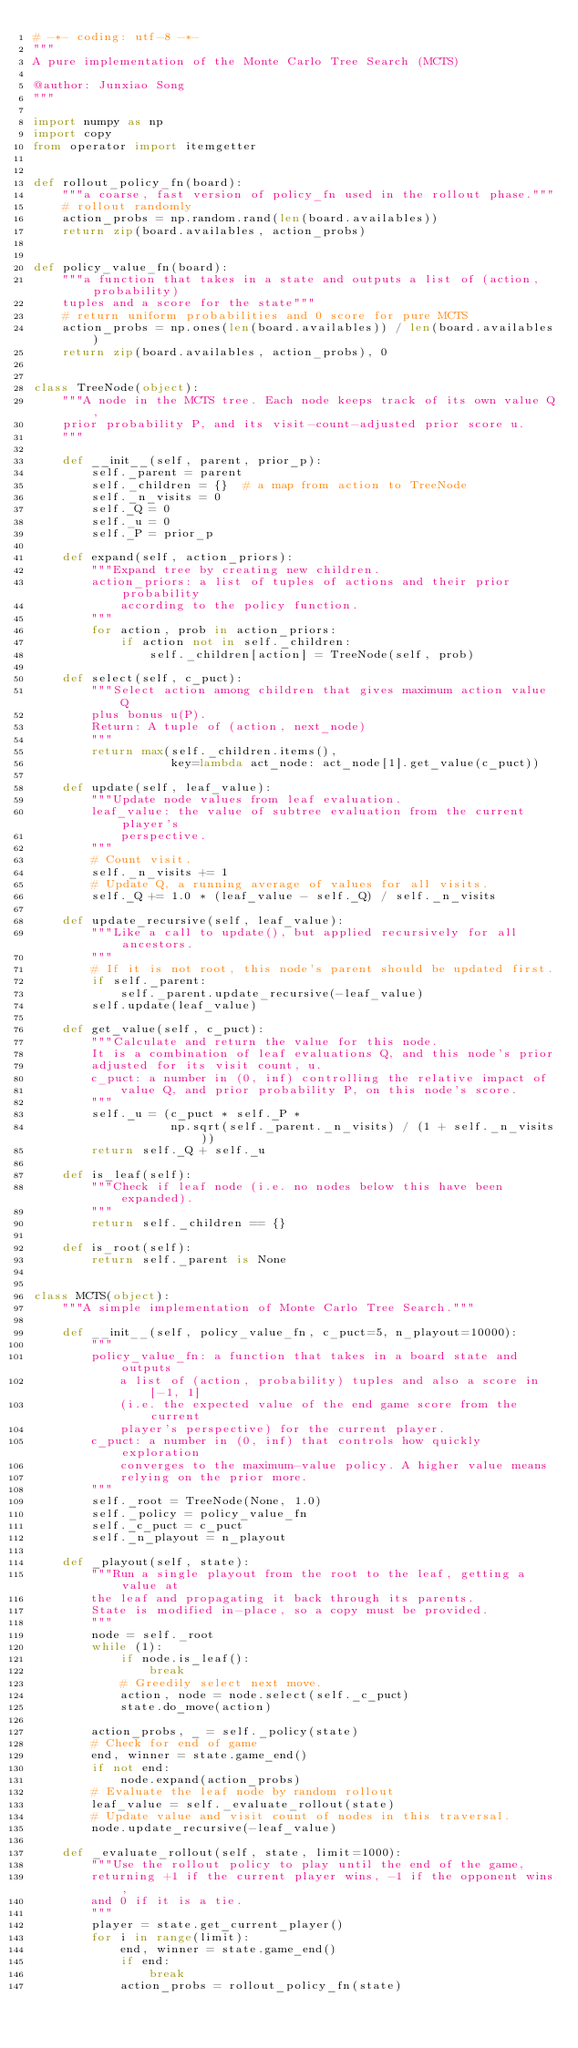Convert code to text. <code><loc_0><loc_0><loc_500><loc_500><_Python_># -*- coding: utf-8 -*-
"""
A pure implementation of the Monte Carlo Tree Search (MCTS)

@author: Junxiao Song
"""

import numpy as np
import copy
from operator import itemgetter


def rollout_policy_fn(board):
    """a coarse, fast version of policy_fn used in the rollout phase."""
    # rollout randomly
    action_probs = np.random.rand(len(board.availables))
    return zip(board.availables, action_probs)


def policy_value_fn(board):
    """a function that takes in a state and outputs a list of (action, probability)
    tuples and a score for the state"""
    # return uniform probabilities and 0 score for pure MCTS
    action_probs = np.ones(len(board.availables)) / len(board.availables)
    return zip(board.availables, action_probs), 0


class TreeNode(object):
    """A node in the MCTS tree. Each node keeps track of its own value Q,
    prior probability P, and its visit-count-adjusted prior score u.
    """

    def __init__(self, parent, prior_p):
        self._parent = parent
        self._children = {}  # a map from action to TreeNode
        self._n_visits = 0
        self._Q = 0
        self._u = 0
        self._P = prior_p

    def expand(self, action_priors):
        """Expand tree by creating new children.
        action_priors: a list of tuples of actions and their prior probability
            according to the policy function.
        """
        for action, prob in action_priors:
            if action not in self._children:
                self._children[action] = TreeNode(self, prob)

    def select(self, c_puct):
        """Select action among children that gives maximum action value Q
        plus bonus u(P).
        Return: A tuple of (action, next_node)
        """
        return max(self._children.items(),
                   key=lambda act_node: act_node[1].get_value(c_puct))

    def update(self, leaf_value):
        """Update node values from leaf evaluation.
        leaf_value: the value of subtree evaluation from the current player's
            perspective.
        """
        # Count visit.
        self._n_visits += 1
        # Update Q, a running average of values for all visits.
        self._Q += 1.0 * (leaf_value - self._Q) / self._n_visits

    def update_recursive(self, leaf_value):
        """Like a call to update(), but applied recursively for all ancestors.
        """
        # If it is not root, this node's parent should be updated first.
        if self._parent:
            self._parent.update_recursive(-leaf_value)
        self.update(leaf_value)

    def get_value(self, c_puct):
        """Calculate and return the value for this node.
        It is a combination of leaf evaluations Q, and this node's prior
        adjusted for its visit count, u.
        c_puct: a number in (0, inf) controlling the relative impact of
            value Q, and prior probability P, on this node's score.
        """
        self._u = (c_puct * self._P *
                   np.sqrt(self._parent._n_visits) / (1 + self._n_visits))
        return self._Q + self._u

    def is_leaf(self):
        """Check if leaf node (i.e. no nodes below this have been expanded).
        """
        return self._children == {}

    def is_root(self):
        return self._parent is None


class MCTS(object):
    """A simple implementation of Monte Carlo Tree Search."""

    def __init__(self, policy_value_fn, c_puct=5, n_playout=10000):
        """
        policy_value_fn: a function that takes in a board state and outputs
            a list of (action, probability) tuples and also a score in [-1, 1]
            (i.e. the expected value of the end game score from the current
            player's perspective) for the current player.
        c_puct: a number in (0, inf) that controls how quickly exploration
            converges to the maximum-value policy. A higher value means
            relying on the prior more.
        """
        self._root = TreeNode(None, 1.0)
        self._policy = policy_value_fn
        self._c_puct = c_puct
        self._n_playout = n_playout

    def _playout(self, state):
        """Run a single playout from the root to the leaf, getting a value at
        the leaf and propagating it back through its parents.
        State is modified in-place, so a copy must be provided.
        """
        node = self._root
        while (1):
            if node.is_leaf():
                break
            # Greedily select next move.
            action, node = node.select(self._c_puct)
            state.do_move(action)

        action_probs, _ = self._policy(state)
        # Check for end of game
        end, winner = state.game_end()
        if not end:
            node.expand(action_probs)
        # Evaluate the leaf node by random rollout
        leaf_value = self._evaluate_rollout(state)
        # Update value and visit count of nodes in this traversal.
        node.update_recursive(-leaf_value)

    def _evaluate_rollout(self, state, limit=1000):
        """Use the rollout policy to play until the end of the game,
        returning +1 if the current player wins, -1 if the opponent wins,
        and 0 if it is a tie.
        """
        player = state.get_current_player()
        for i in range(limit):
            end, winner = state.game_end()
            if end:
                break
            action_probs = rollout_policy_fn(state)</code> 